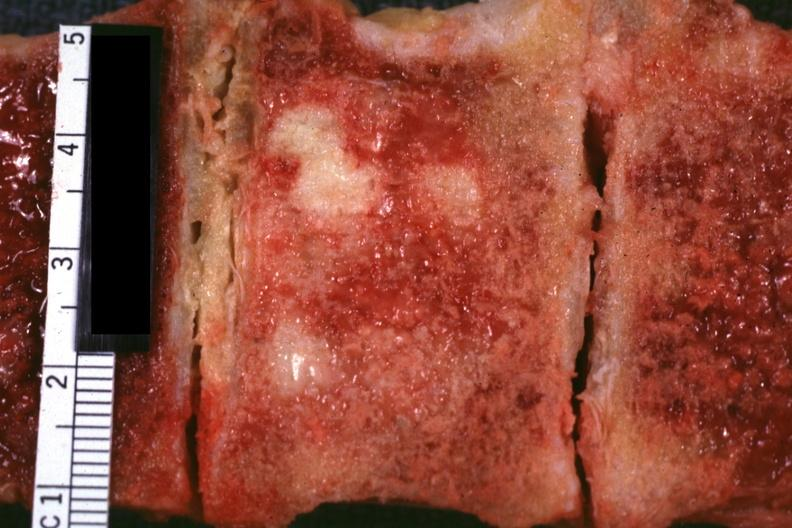what is present?
Answer the question using a single word or phrase. Joints 